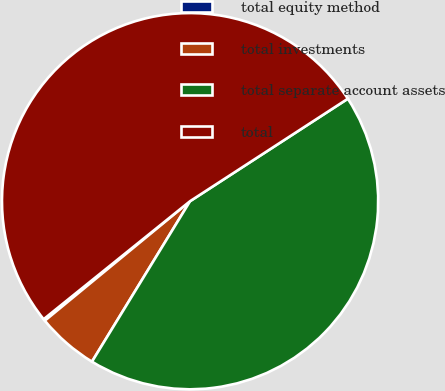Convert chart to OTSL. <chart><loc_0><loc_0><loc_500><loc_500><pie_chart><fcel>total equity method<fcel>total investments<fcel>total separate account assets<fcel>total<nl><fcel>0.16%<fcel>5.31%<fcel>42.9%<fcel>51.63%<nl></chart> 